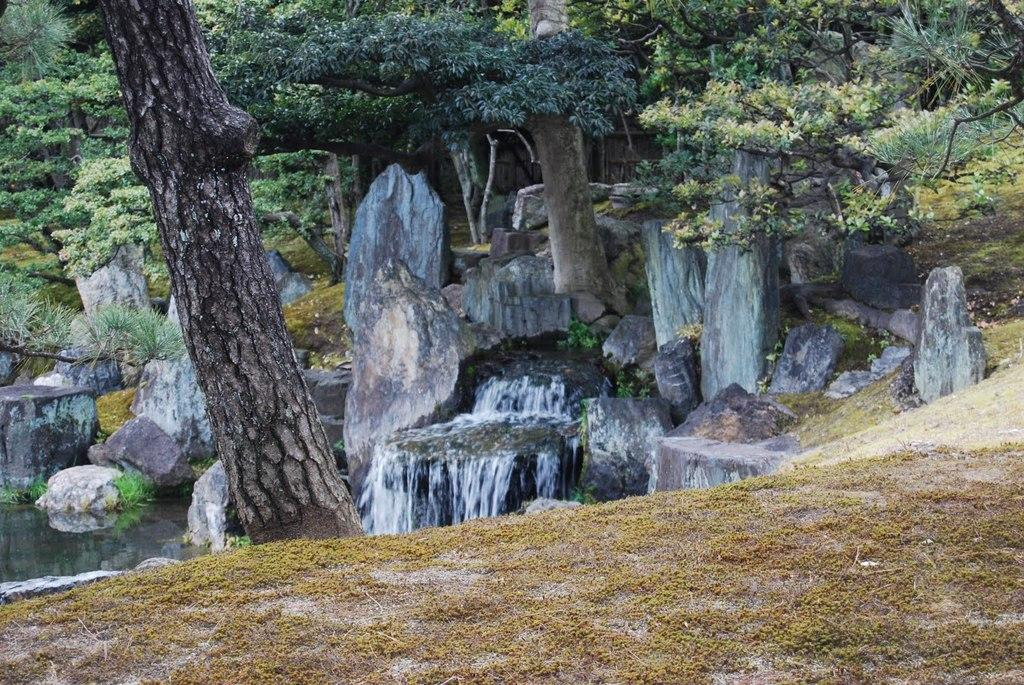What type of terrain is visible in the foreground of the image? There is grass land in the foreground of the image. What can be seen in the foreground of the image besides the grass land? There is a tree trunk in the foreground of the image. What natural feature is visible in the background of the image? There is a waterfall in the background of the image. What else can be seen in the background of the image besides the waterfall? There are rocks, water, and trees in the background of the image. What type of chalk is being used to draw on the plate in the image? There is no chalk or plate present in the image. What branch is the bird perched on in the image? There is no bird or branch present in the image. 